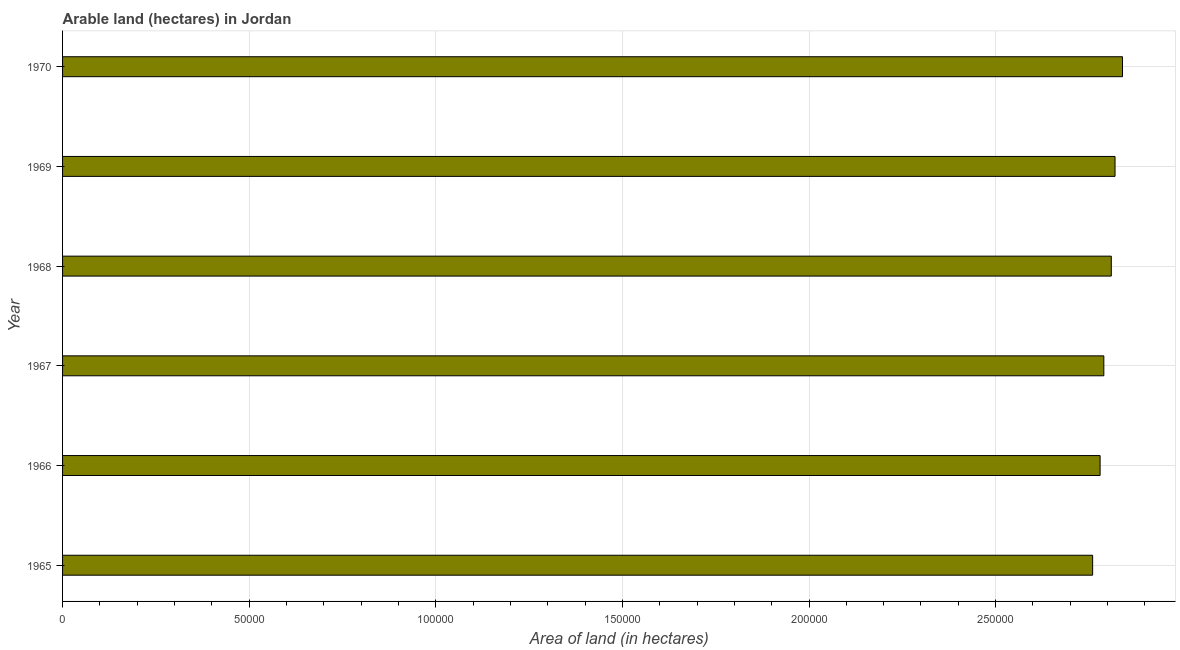Does the graph contain any zero values?
Offer a very short reply. No. What is the title of the graph?
Provide a short and direct response. Arable land (hectares) in Jordan. What is the label or title of the X-axis?
Provide a succinct answer. Area of land (in hectares). What is the label or title of the Y-axis?
Offer a very short reply. Year. What is the area of land in 1970?
Provide a succinct answer. 2.84e+05. Across all years, what is the maximum area of land?
Your response must be concise. 2.84e+05. Across all years, what is the minimum area of land?
Your response must be concise. 2.76e+05. In which year was the area of land minimum?
Your answer should be compact. 1965. What is the sum of the area of land?
Your response must be concise. 1.68e+06. What is the difference between the area of land in 1969 and 1970?
Offer a terse response. -2000. What is the median area of land?
Give a very brief answer. 2.80e+05. What is the difference between the highest and the second highest area of land?
Your answer should be very brief. 2000. What is the difference between the highest and the lowest area of land?
Offer a very short reply. 8000. In how many years, is the area of land greater than the average area of land taken over all years?
Your response must be concise. 3. Are all the bars in the graph horizontal?
Ensure brevity in your answer.  Yes. What is the difference between two consecutive major ticks on the X-axis?
Make the answer very short. 5.00e+04. Are the values on the major ticks of X-axis written in scientific E-notation?
Your response must be concise. No. What is the Area of land (in hectares) in 1965?
Give a very brief answer. 2.76e+05. What is the Area of land (in hectares) of 1966?
Your response must be concise. 2.78e+05. What is the Area of land (in hectares) in 1967?
Keep it short and to the point. 2.79e+05. What is the Area of land (in hectares) of 1968?
Provide a short and direct response. 2.81e+05. What is the Area of land (in hectares) of 1969?
Provide a succinct answer. 2.82e+05. What is the Area of land (in hectares) of 1970?
Offer a terse response. 2.84e+05. What is the difference between the Area of land (in hectares) in 1965 and 1966?
Offer a terse response. -2000. What is the difference between the Area of land (in hectares) in 1965 and 1967?
Your answer should be compact. -3000. What is the difference between the Area of land (in hectares) in 1965 and 1968?
Make the answer very short. -5000. What is the difference between the Area of land (in hectares) in 1965 and 1969?
Your response must be concise. -6000. What is the difference between the Area of land (in hectares) in 1965 and 1970?
Offer a very short reply. -8000. What is the difference between the Area of land (in hectares) in 1966 and 1967?
Provide a short and direct response. -1000. What is the difference between the Area of land (in hectares) in 1966 and 1968?
Your answer should be very brief. -3000. What is the difference between the Area of land (in hectares) in 1966 and 1969?
Your answer should be compact. -4000. What is the difference between the Area of land (in hectares) in 1966 and 1970?
Your answer should be very brief. -6000. What is the difference between the Area of land (in hectares) in 1967 and 1968?
Your response must be concise. -2000. What is the difference between the Area of land (in hectares) in 1967 and 1969?
Offer a very short reply. -3000. What is the difference between the Area of land (in hectares) in 1967 and 1970?
Give a very brief answer. -5000. What is the difference between the Area of land (in hectares) in 1968 and 1969?
Your response must be concise. -1000. What is the difference between the Area of land (in hectares) in 1968 and 1970?
Provide a short and direct response. -3000. What is the difference between the Area of land (in hectares) in 1969 and 1970?
Your response must be concise. -2000. What is the ratio of the Area of land (in hectares) in 1965 to that in 1966?
Ensure brevity in your answer.  0.99. What is the ratio of the Area of land (in hectares) in 1965 to that in 1967?
Provide a succinct answer. 0.99. What is the ratio of the Area of land (in hectares) in 1965 to that in 1968?
Your response must be concise. 0.98. What is the ratio of the Area of land (in hectares) in 1965 to that in 1969?
Ensure brevity in your answer.  0.98. What is the ratio of the Area of land (in hectares) in 1966 to that in 1967?
Provide a succinct answer. 1. What is the ratio of the Area of land (in hectares) in 1966 to that in 1969?
Ensure brevity in your answer.  0.99. What is the ratio of the Area of land (in hectares) in 1966 to that in 1970?
Provide a short and direct response. 0.98. What is the ratio of the Area of land (in hectares) in 1967 to that in 1969?
Provide a succinct answer. 0.99. What is the ratio of the Area of land (in hectares) in 1967 to that in 1970?
Your response must be concise. 0.98. 